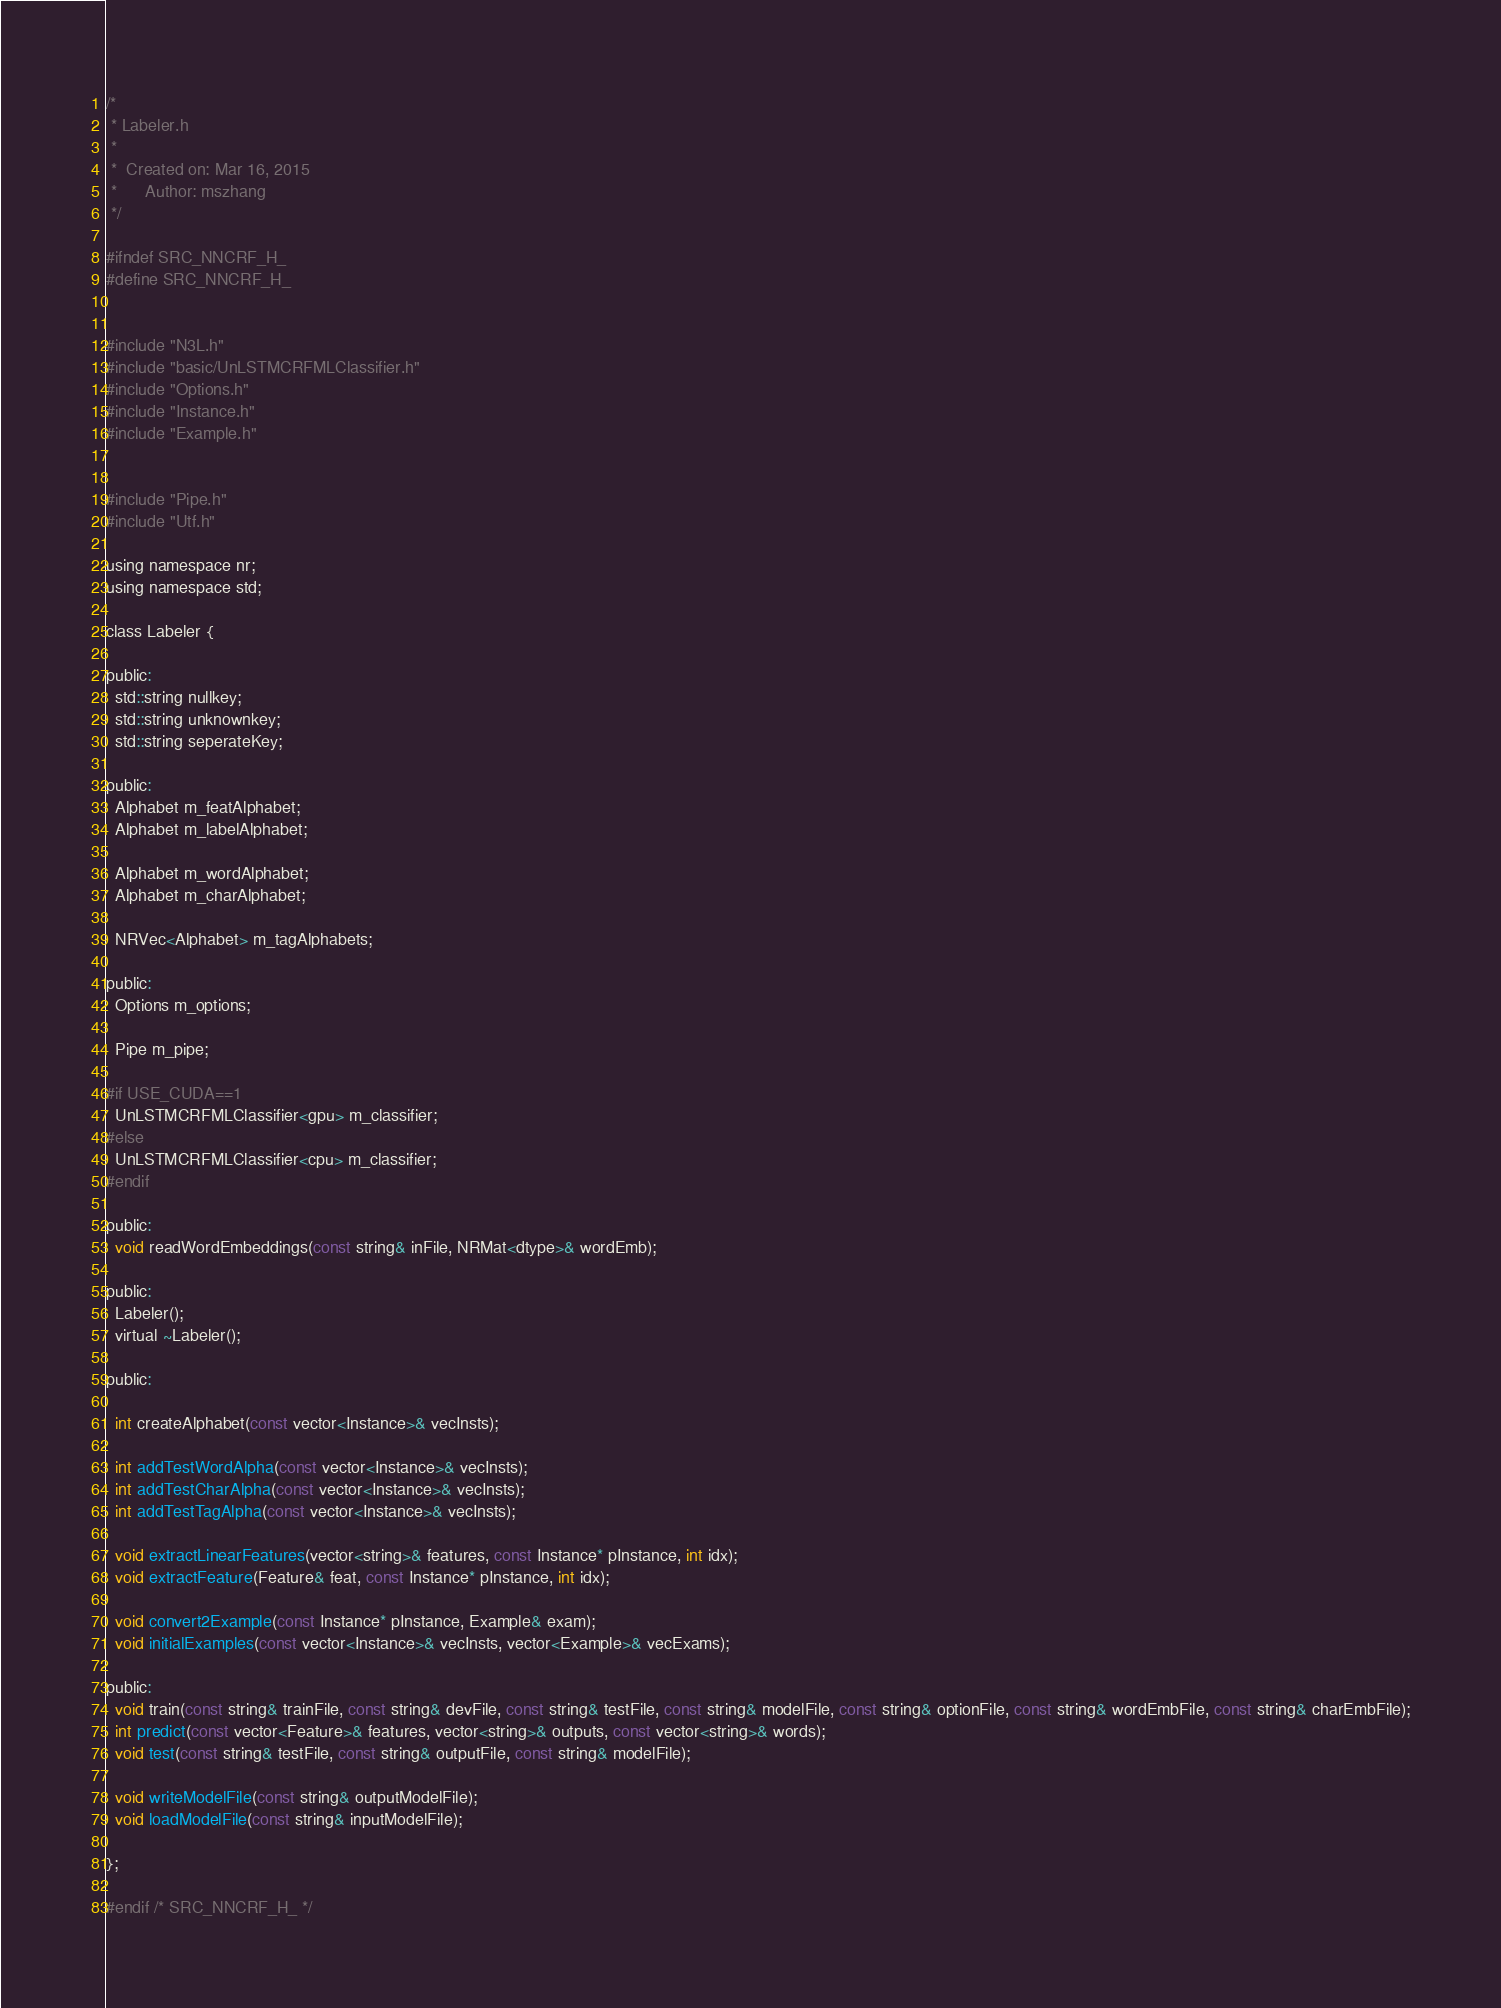Convert code to text. <code><loc_0><loc_0><loc_500><loc_500><_C_>/*
 * Labeler.h
 *
 *  Created on: Mar 16, 2015
 *      Author: mszhang
 */

#ifndef SRC_NNCRF_H_
#define SRC_NNCRF_H_


#include "N3L.h"
#include "basic/UnLSTMCRFMLClassifier.h"
#include "Options.h"
#include "Instance.h"
#include "Example.h"


#include "Pipe.h"
#include "Utf.h"

using namespace nr;
using namespace std;

class Labeler {

public:
  std::string nullkey;
  std::string unknownkey;
  std::string seperateKey;

public:
  Alphabet m_featAlphabet;
  Alphabet m_labelAlphabet;

  Alphabet m_wordAlphabet;
  Alphabet m_charAlphabet;

  NRVec<Alphabet> m_tagAlphabets;

public:
  Options m_options;

  Pipe m_pipe;

#if USE_CUDA==1
  UnLSTMCRFMLClassifier<gpu> m_classifier;
#else
  UnLSTMCRFMLClassifier<cpu> m_classifier;
#endif

public:
  void readWordEmbeddings(const string& inFile, NRMat<dtype>& wordEmb);

public:
  Labeler();
  virtual ~Labeler();

public:

  int createAlphabet(const vector<Instance>& vecInsts);

  int addTestWordAlpha(const vector<Instance>& vecInsts);
  int addTestCharAlpha(const vector<Instance>& vecInsts);
  int addTestTagAlpha(const vector<Instance>& vecInsts);

  void extractLinearFeatures(vector<string>& features, const Instance* pInstance, int idx);
  void extractFeature(Feature& feat, const Instance* pInstance, int idx);

  void convert2Example(const Instance* pInstance, Example& exam);
  void initialExamples(const vector<Instance>& vecInsts, vector<Example>& vecExams);

public:
  void train(const string& trainFile, const string& devFile, const string& testFile, const string& modelFile, const string& optionFile, const string& wordEmbFile, const string& charEmbFile);
  int predict(const vector<Feature>& features, vector<string>& outputs, const vector<string>& words);
  void test(const string& testFile, const string& outputFile, const string& modelFile);

  void writeModelFile(const string& outputModelFile);
  void loadModelFile(const string& inputModelFile);

};

#endif /* SRC_NNCRF_H_ */
</code> 